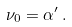<formula> <loc_0><loc_0><loc_500><loc_500>\nu _ { 0 } = \alpha ^ { \prime } \, .</formula> 